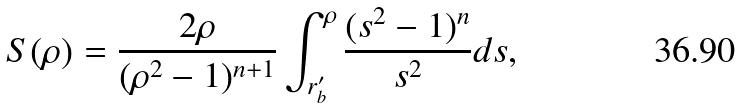Convert formula to latex. <formula><loc_0><loc_0><loc_500><loc_500>S ( \rho ) = \frac { 2 \rho } { ( \rho ^ { 2 } - 1 ) ^ { n + 1 } } \int ^ { \rho } _ { r ^ { \prime } _ { b } } \frac { ( s ^ { 2 } - 1 ) ^ { n } } { s ^ { 2 } } d s ,</formula> 